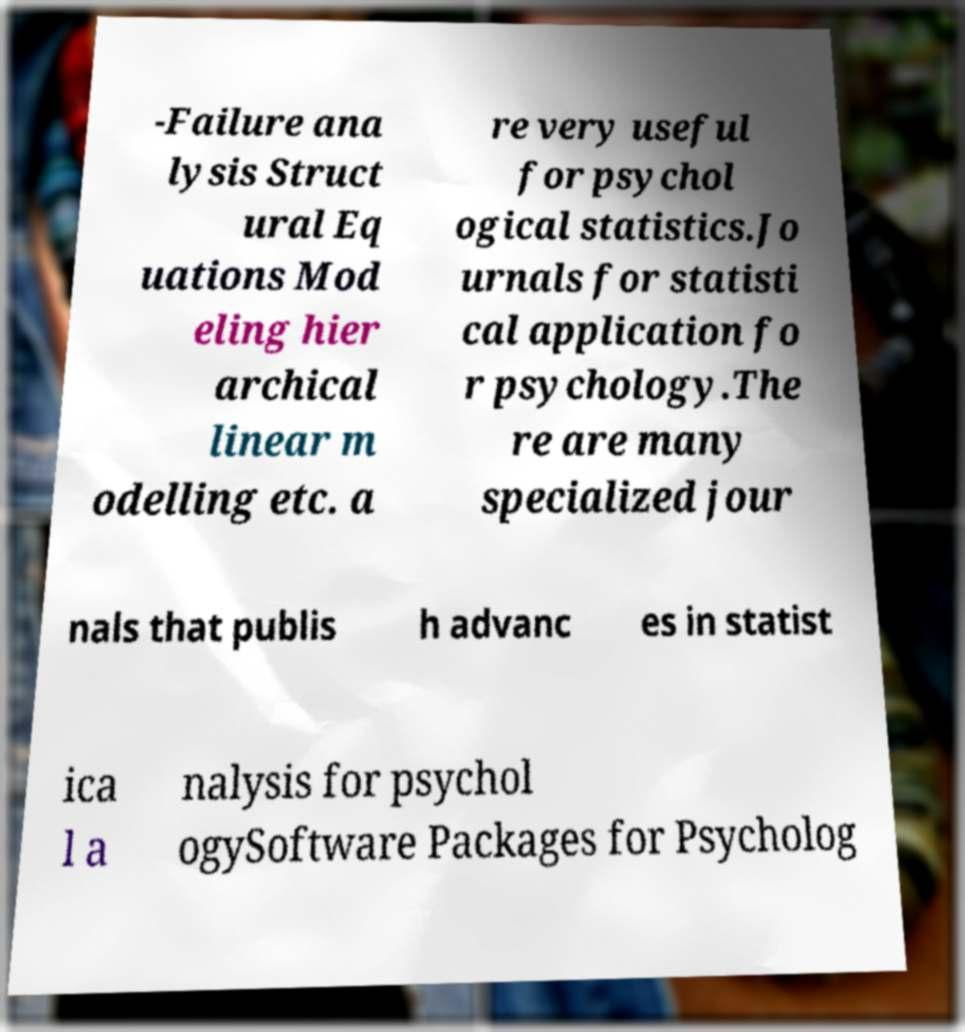Can you accurately transcribe the text from the provided image for me? -Failure ana lysis Struct ural Eq uations Mod eling hier archical linear m odelling etc. a re very useful for psychol ogical statistics.Jo urnals for statisti cal application fo r psychology.The re are many specialized jour nals that publis h advanc es in statist ica l a nalysis for psychol ogySoftware Packages for Psycholog 